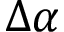Convert formula to latex. <formula><loc_0><loc_0><loc_500><loc_500>\Delta \alpha</formula> 